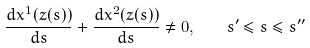<formula> <loc_0><loc_0><loc_500><loc_500>\frac { d x ^ { 1 } ( z ( s ) ) } { d s } + \frac { d x ^ { 2 } ( z ( s ) ) } { d s } \neq 0 , \quad s ^ { \prime } \leq s \leq s ^ { \prime \prime }</formula> 